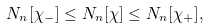Convert formula to latex. <formula><loc_0><loc_0><loc_500><loc_500>N _ { n } [ \chi _ { - } ] \leq N _ { n } [ \chi ] \leq N _ { n } [ \chi _ { + } ] ,</formula> 